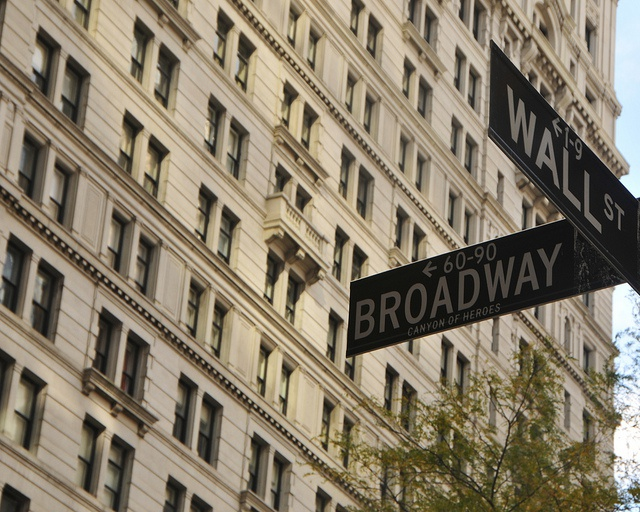Describe the objects in this image and their specific colors. I can see various objects in this image with different colors. 